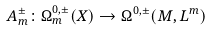Convert formula to latex. <formula><loc_0><loc_0><loc_500><loc_500>A ^ { \pm } _ { m } \colon \Omega ^ { 0 , \pm } _ { m } ( X ) \rightarrow \Omega ^ { 0 , \pm } ( M , L ^ { m } )</formula> 